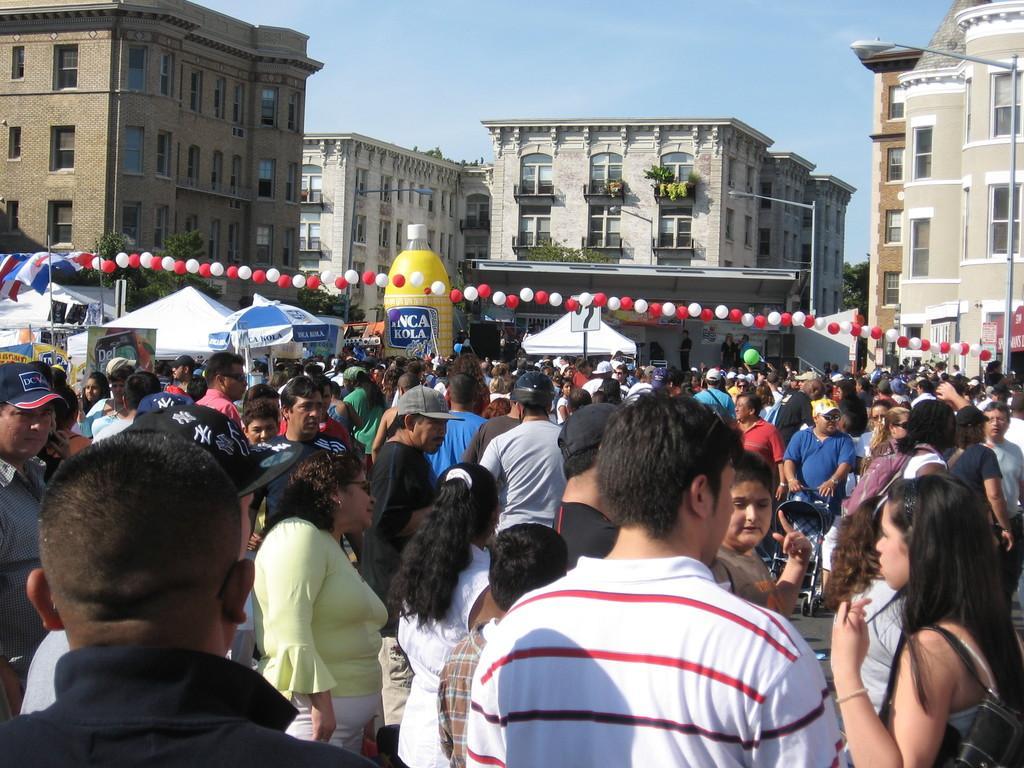How would you summarize this image in a sentence or two? In this image there are a group of people standing in the town center, behind them there are buildings. 